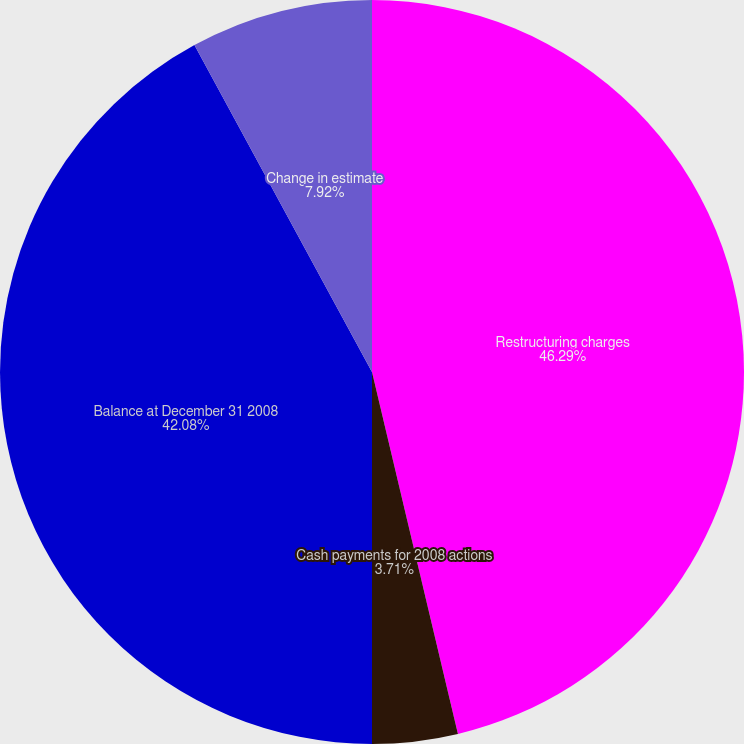<chart> <loc_0><loc_0><loc_500><loc_500><pie_chart><fcel>Restructuring charges<fcel>Cash payments for 2008 actions<fcel>Balance at December 31 2008<fcel>Change in estimate<nl><fcel>46.29%<fcel>3.71%<fcel>42.08%<fcel>7.92%<nl></chart> 